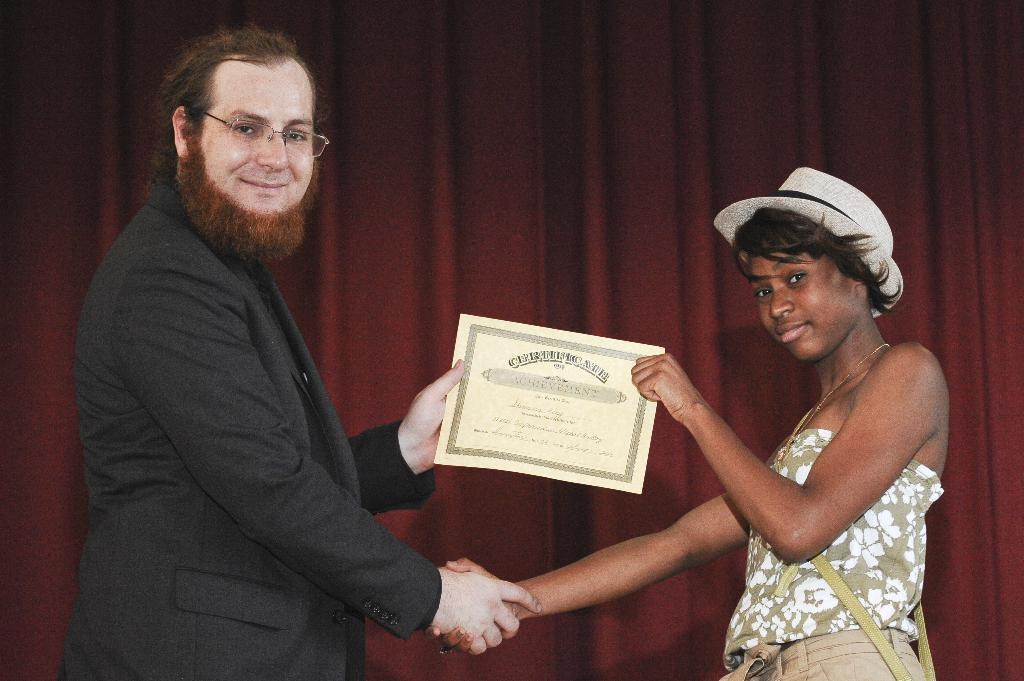Who are the people in the foreground of the image? There is a man and a woman in the foreground of the image. What are the man and woman holding in the image? The man and woman are holding a certificate in the image. What can be seen in the background of the image? There is a red color curtain in the background of the image. What is the source of power in the image? There is no source of power mentioned or depicted in the image. How does the woman in the image attract attention? The image does not provide information about how the woman attracts attention, as it only shows her holding a certificate with the man. 